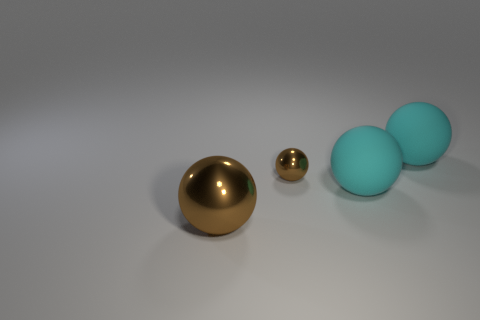Add 3 brown shiny things. How many objects exist? 7 Subtract all cyan spheres. How many spheres are left? 2 Subtract all small metallic balls. How many balls are left? 3 Subtract 0 yellow blocks. How many objects are left? 4 Subtract all gray spheres. Subtract all green blocks. How many spheres are left? 4 Subtract all cyan blocks. How many cyan balls are left? 2 Subtract all big cyan metal cylinders. Subtract all matte spheres. How many objects are left? 2 Add 1 small brown metal objects. How many small brown metal objects are left? 2 Add 4 cyan matte things. How many cyan matte things exist? 6 